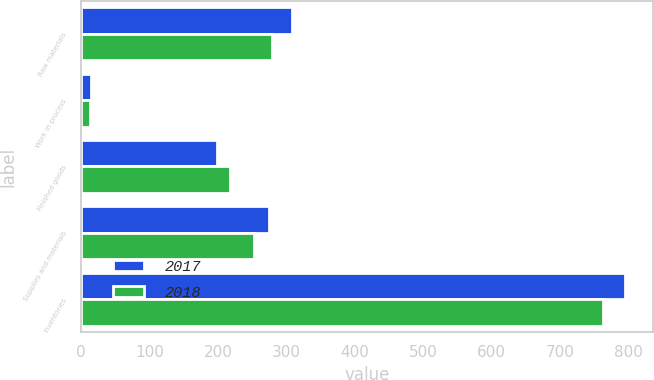Convert chart. <chart><loc_0><loc_0><loc_500><loc_500><stacked_bar_chart><ecel><fcel>Raw materials<fcel>Work in process<fcel>Finished goods<fcel>Supplies and materials<fcel>Inventories<nl><fcel>2017<fcel>307.8<fcel>13.9<fcel>199<fcel>274.9<fcel>795.6<nl><fcel>2018<fcel>279.8<fcel>12.6<fcel>217<fcel>253.1<fcel>762.5<nl></chart> 